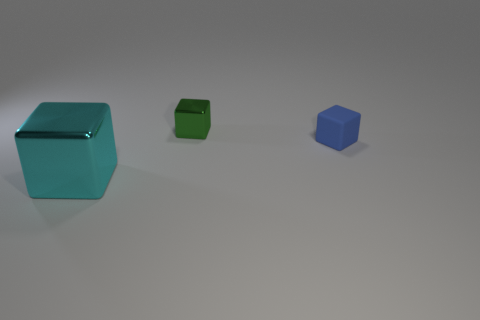Add 1 large blue spheres. How many objects exist? 4 Subtract all cyan metallic spheres. Subtract all shiny cubes. How many objects are left? 1 Add 1 green objects. How many green objects are left? 2 Add 1 tiny blue rubber objects. How many tiny blue rubber objects exist? 2 Subtract 0 cyan spheres. How many objects are left? 3 